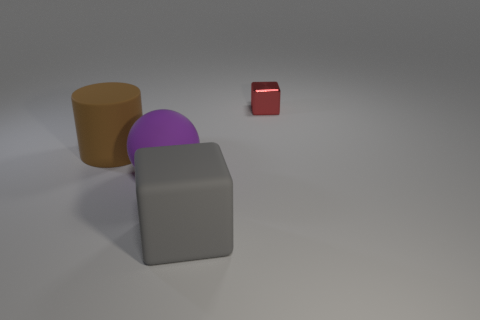Are there fewer brown cylinders that are to the left of the cylinder than tiny cyan matte cylinders?
Ensure brevity in your answer.  No. There is a cube that is in front of the cube behind the block in front of the tiny red metallic object; how big is it?
Keep it short and to the point. Large. There is a object that is both behind the gray rubber block and in front of the cylinder; what color is it?
Provide a short and direct response. Purple. How many tiny cyan matte balls are there?
Provide a succinct answer. 0. Are there any other things that have the same size as the red block?
Your response must be concise. No. Is the material of the gray block the same as the cylinder?
Ensure brevity in your answer.  Yes. There is a cube that is on the left side of the red metal thing; does it have the same size as the cube that is to the right of the big gray object?
Give a very brief answer. No. Are there fewer big rubber blocks than large objects?
Offer a very short reply. Yes. What number of shiny objects are large purple spheres or tiny yellow balls?
Your response must be concise. 0. Are there any matte objects that are behind the block that is in front of the cylinder?
Offer a very short reply. Yes. 